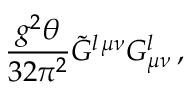<formula> <loc_0><loc_0><loc_500><loc_500>\frac { g ^ { 2 } \theta } { 3 2 \pi ^ { 2 } } \tilde { G } ^ { l \, \mu \nu } G _ { \mu \nu } ^ { l } \, ,</formula> 